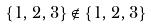<formula> <loc_0><loc_0><loc_500><loc_500>\{ 1 , 2 , 3 \} \notin \{ 1 , 2 , 3 \}</formula> 